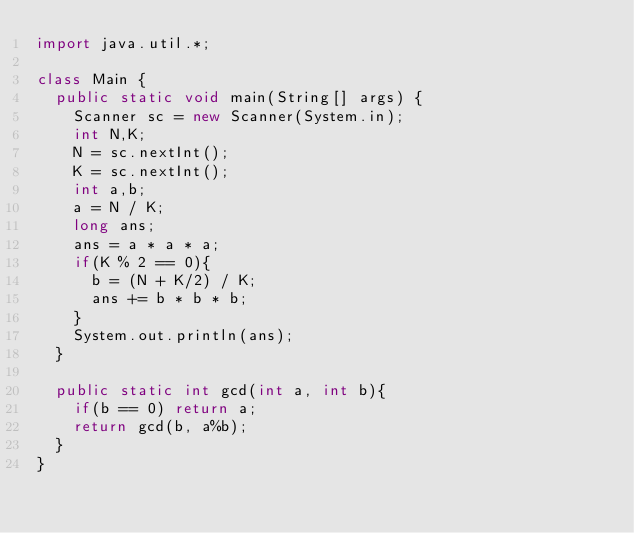<code> <loc_0><loc_0><loc_500><loc_500><_Java_>import java.util.*;

class Main {
  public static void main(String[] args) {
    Scanner sc = new Scanner(System.in);
    int N,K;
    N = sc.nextInt();
    K = sc.nextInt();
    int a,b;
    a = N / K;
    long ans;
    ans = a * a * a;
    if(K % 2 == 0){
      b = (N + K/2) / K;
      ans += b * b * b;
    }
    System.out.println(ans);
  }

  public static int gcd(int a, int b){
    if(b == 0) return a;
    return gcd(b, a%b);
  }
}</code> 